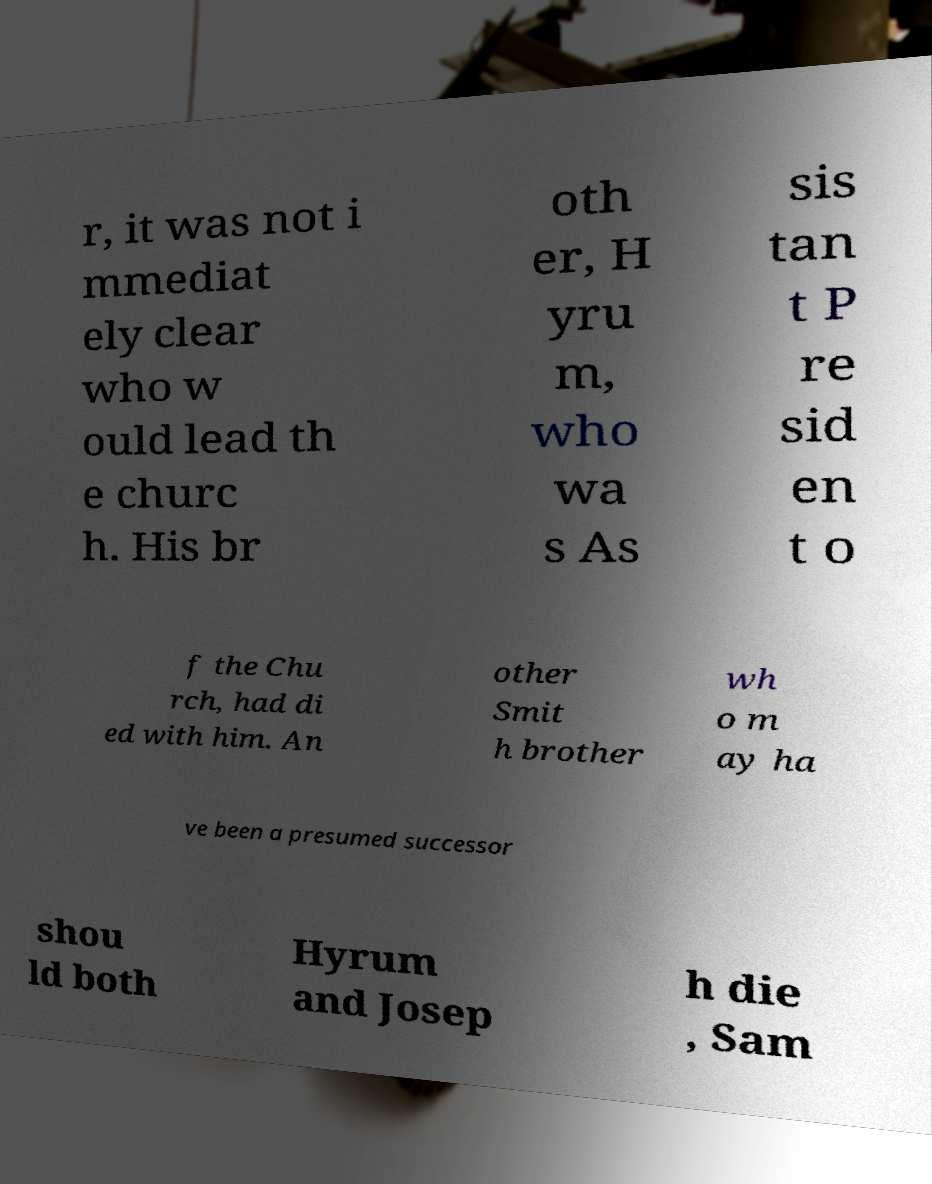Please identify and transcribe the text found in this image. r, it was not i mmediat ely clear who w ould lead th e churc h. His br oth er, H yru m, who wa s As sis tan t P re sid en t o f the Chu rch, had di ed with him. An other Smit h brother wh o m ay ha ve been a presumed successor shou ld both Hyrum and Josep h die , Sam 